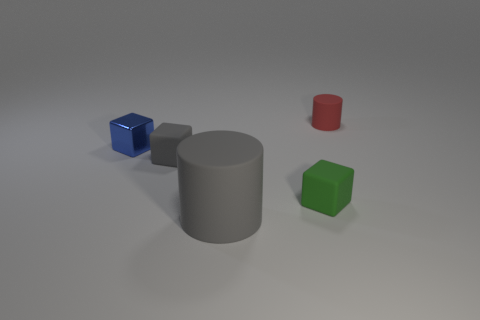There is a cylinder that is to the left of the rubber object that is behind the blue thing; what is its size? The cylinder to the left of the rubber object, which is behind the blue cube, appears to be of a medium size compared to the other objects in the image. 